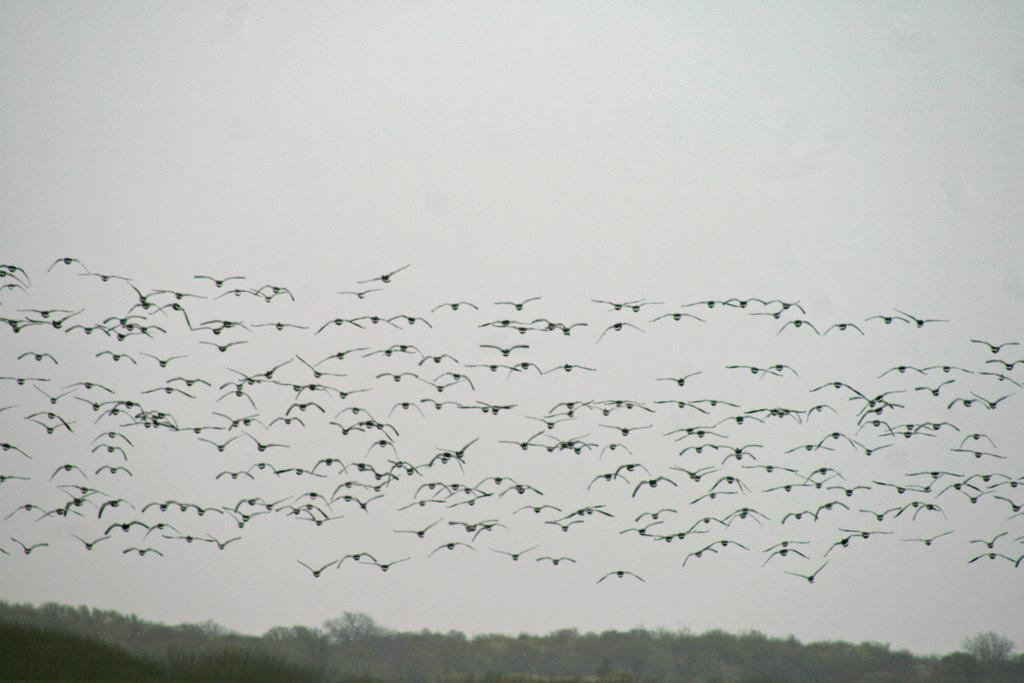Please provide a concise description of this image. In this image there are birds, flying in the sky at the bottom there are trees. 